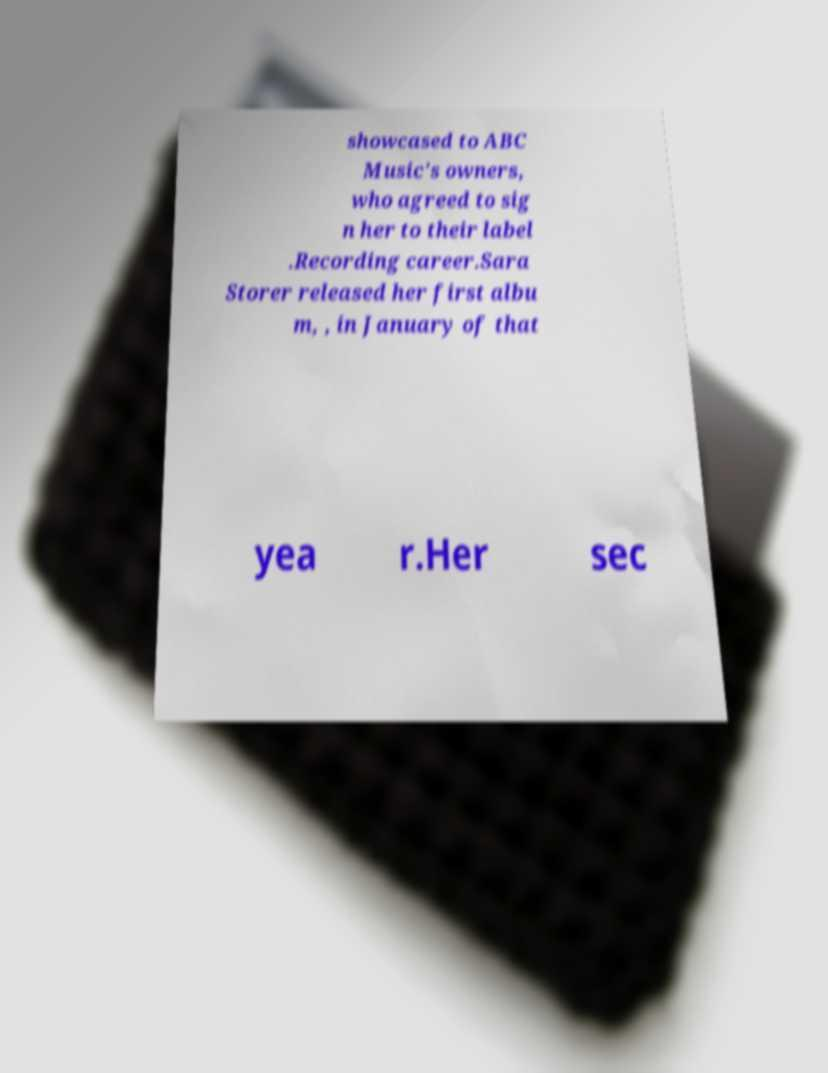Can you read and provide the text displayed in the image?This photo seems to have some interesting text. Can you extract and type it out for me? showcased to ABC Music's owners, who agreed to sig n her to their label .Recording career.Sara Storer released her first albu m, , in January of that yea r.Her sec 